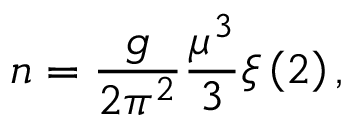Convert formula to latex. <formula><loc_0><loc_0><loc_500><loc_500>n = \frac { g } { 2 \pi ^ { 2 } } \frac { \mu ^ { 3 } } { 3 } \xi \left ( 2 \right ) ,</formula> 